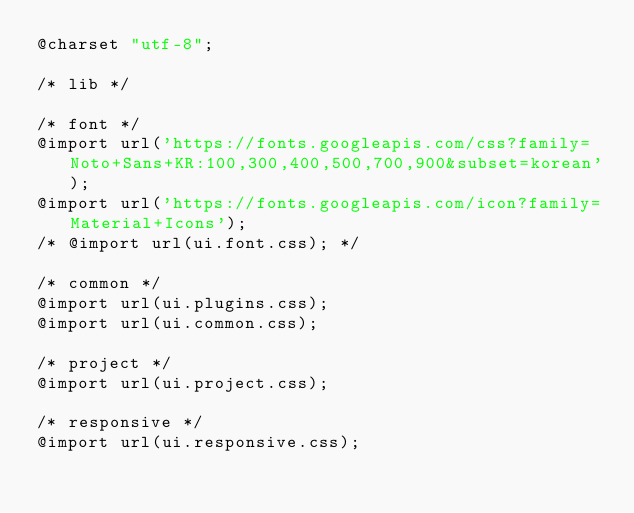Convert code to text. <code><loc_0><loc_0><loc_500><loc_500><_CSS_>@charset "utf-8";

/* lib */

/* font */
@import url('https://fonts.googleapis.com/css?family=Noto+Sans+KR:100,300,400,500,700,900&subset=korean');
@import url('https://fonts.googleapis.com/icon?family=Material+Icons');
/* @import url(ui.font.css); */

/* common */
@import url(ui.plugins.css);
@import url(ui.common.css);

/* project */
@import url(ui.project.css);

/* responsive */
@import url(ui.responsive.css);
</code> 